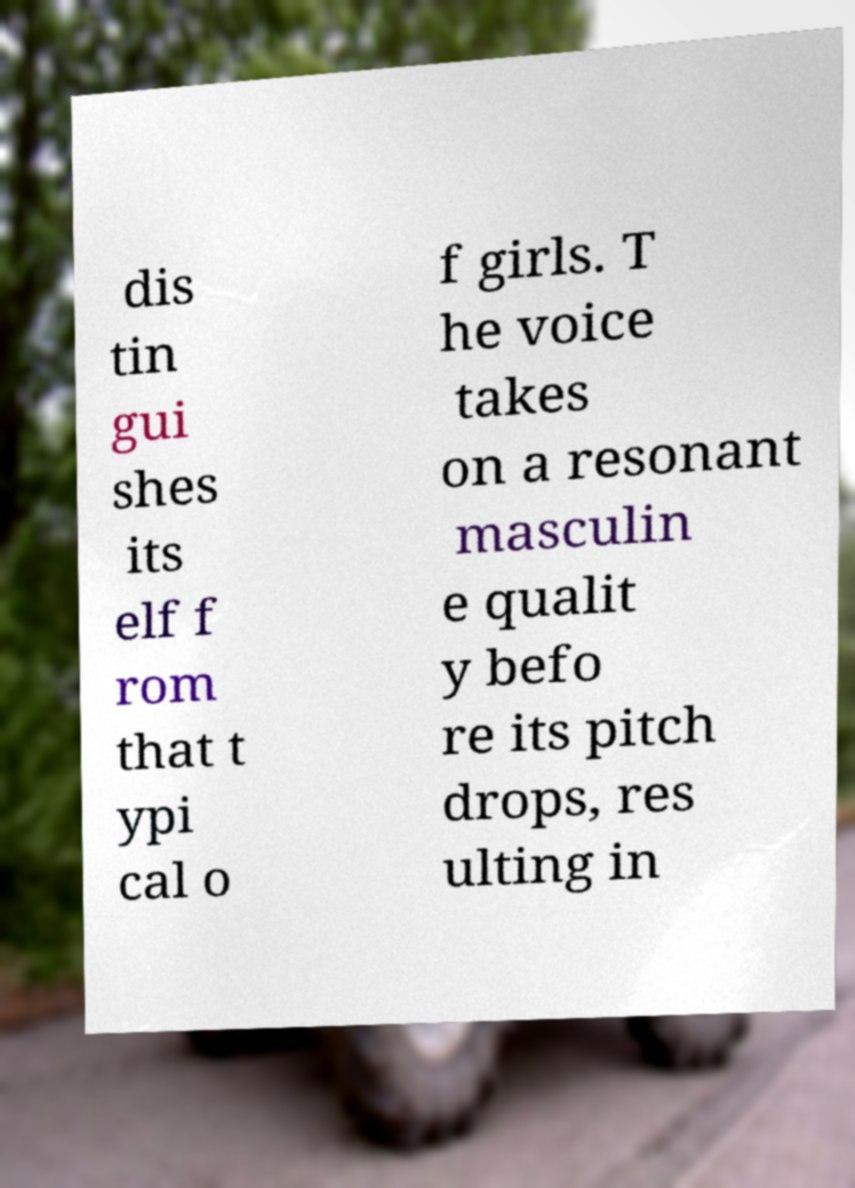Could you assist in decoding the text presented in this image and type it out clearly? dis tin gui shes its elf f rom that t ypi cal o f girls. T he voice takes on a resonant masculin e qualit y befo re its pitch drops, res ulting in 